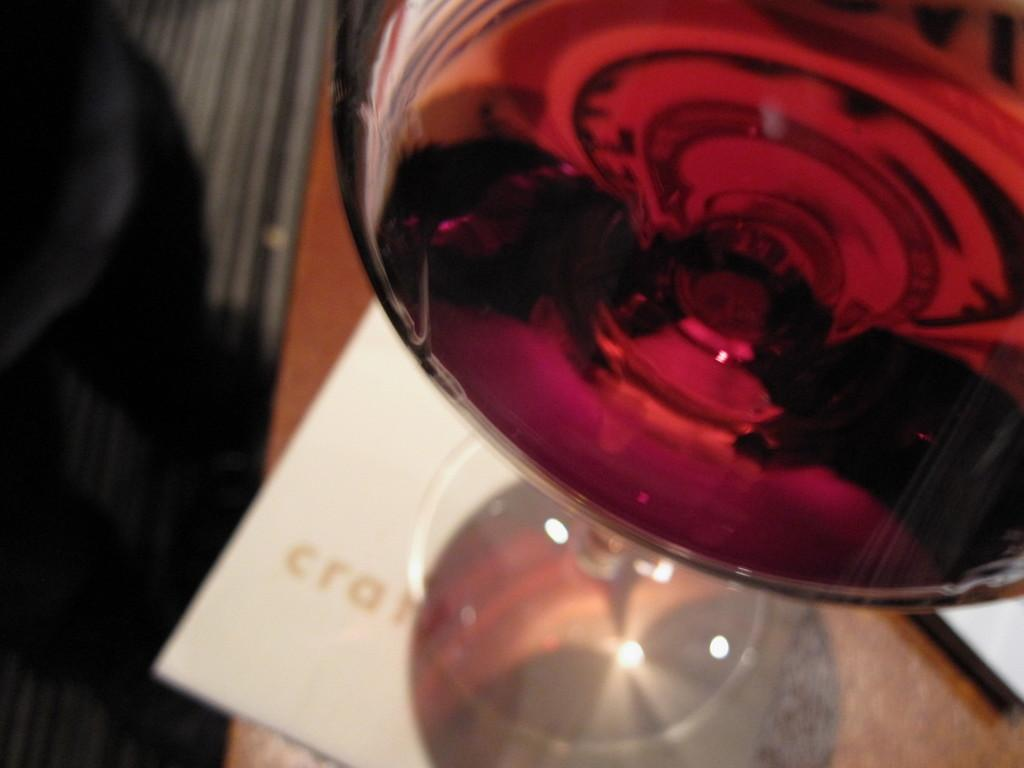What is in the wine glass that is visible in the image? The wine glass is filled with a drink. Where is the wine glass placed in the image? The wine glass is on a paper, which is on a table. What is visible on the left side of the image? The floor is visible on the left side of the image. What type of string is being used to create the impulse in the image? There is no string or impulse present in the image; it features a wine glass on a paper on a table. Is there a girl visible in the image? No, there is no girl present in the image. 